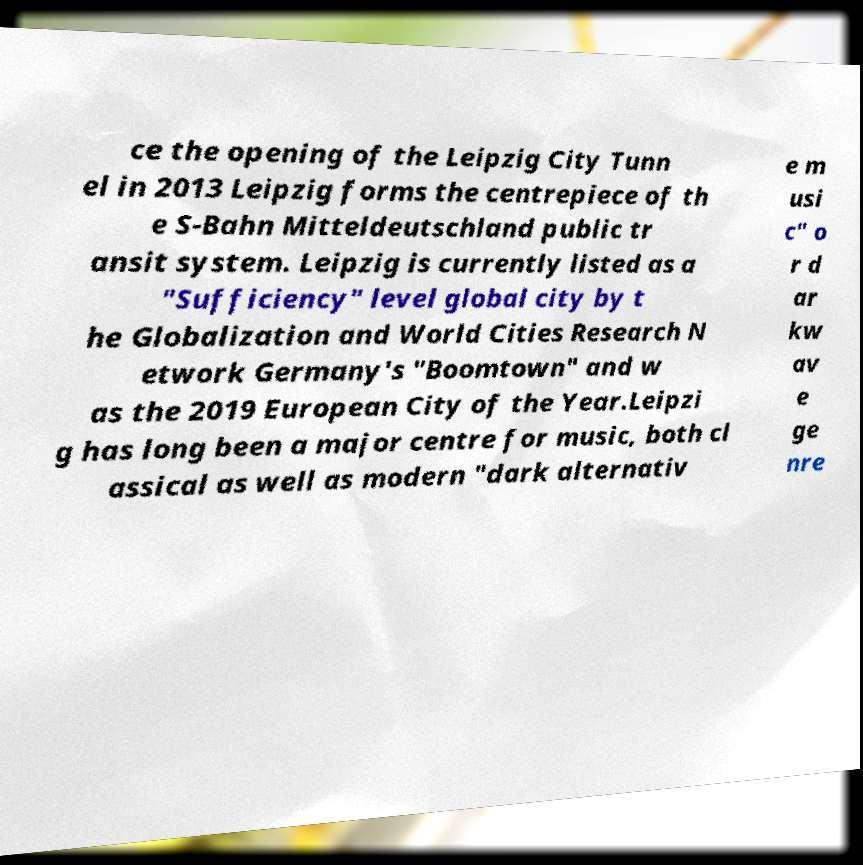Could you assist in decoding the text presented in this image and type it out clearly? ce the opening of the Leipzig City Tunn el in 2013 Leipzig forms the centrepiece of th e S-Bahn Mitteldeutschland public tr ansit system. Leipzig is currently listed as a "Sufficiency" level global city by t he Globalization and World Cities Research N etwork Germany's "Boomtown" and w as the 2019 European City of the Year.Leipzi g has long been a major centre for music, both cl assical as well as modern "dark alternativ e m usi c" o r d ar kw av e ge nre 